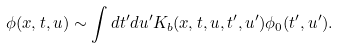<formula> <loc_0><loc_0><loc_500><loc_500>\phi ( x , t , u ) \sim \int { d t ^ { \prime } d u ^ { \prime } } K _ { b } ( x , t , u , t ^ { \prime } , u ^ { \prime } ) \phi _ { 0 } ( t ^ { \prime } , u ^ { \prime } ) .</formula> 